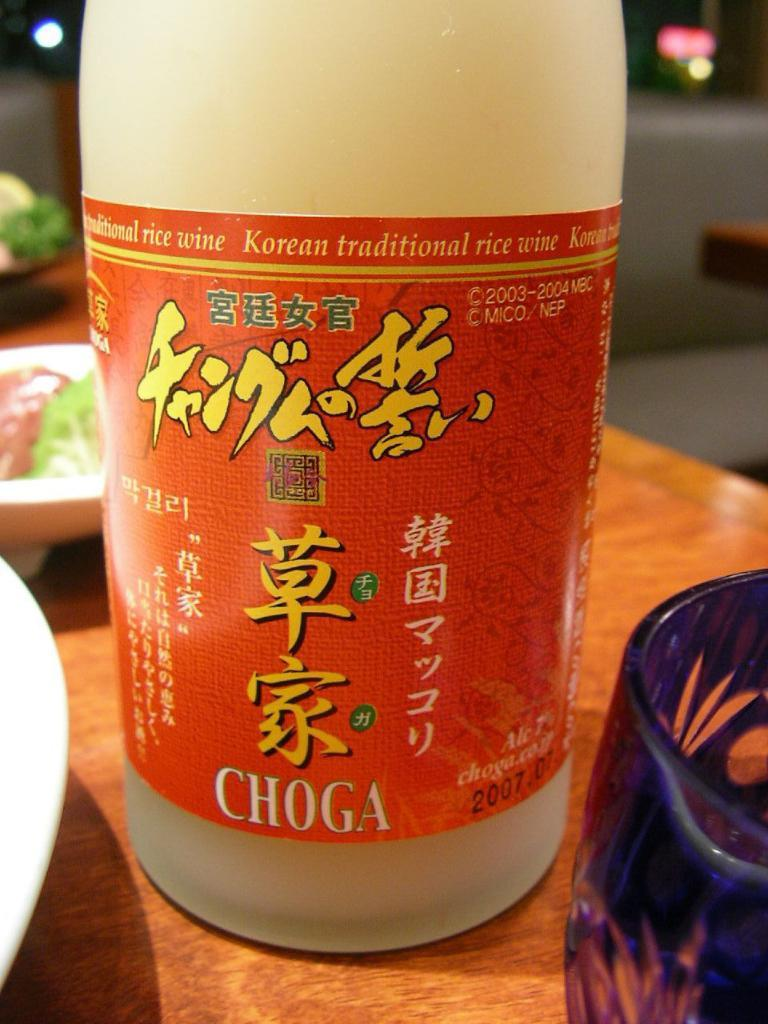<image>
Describe the image concisely. A bottle of Choga brand Korean rice wine 